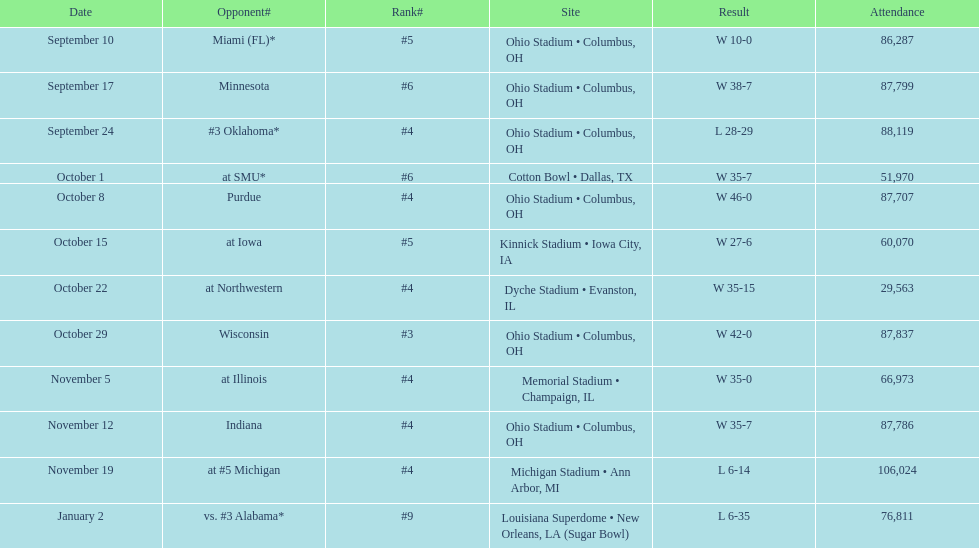How many matches did this team win throughout this season? 9. 